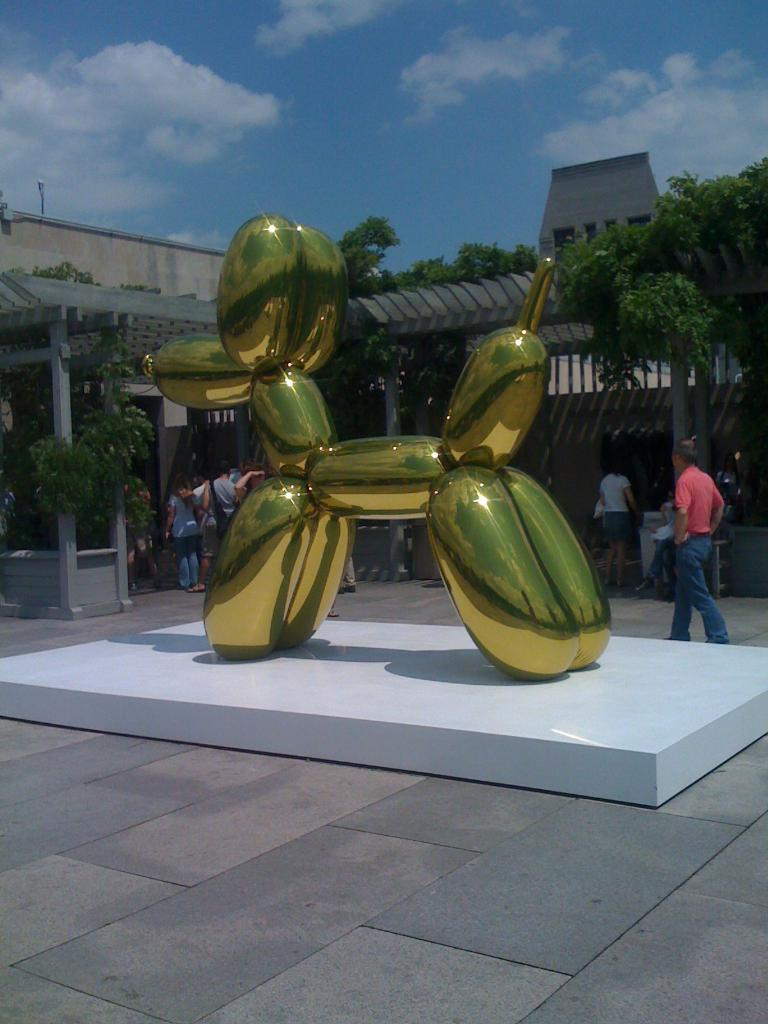What is the main subject of the image? There is a structure of a dog in the image. What are the people in the image doing? The people are standing and walking on the road in the image. What can be seen in the background of the image? There is a building, trees, and the sky visible in the background of the image. What type of arm is visible on the dog in the image? There is no arm present on the dog in the image, as it is a structure and not a living creature. What type of blade can be seen in the hands of the people walking on the road? There are no blades visible in the hands of the people walking on the road in the image. 